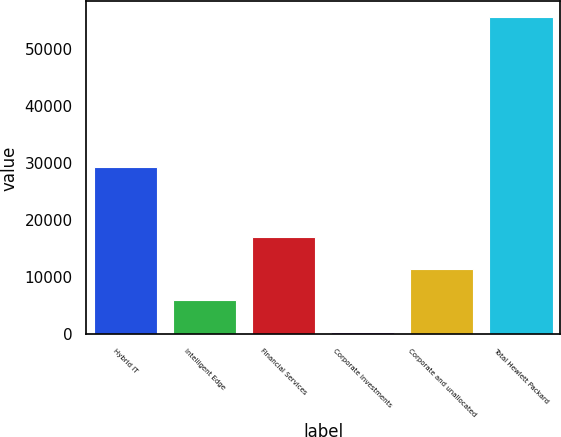Convert chart. <chart><loc_0><loc_0><loc_500><loc_500><bar_chart><fcel>Hybrid IT<fcel>Intelligent Edge<fcel>Financial Services<fcel>Corporate Investments<fcel>Corporate and unallocated<fcel>Total Hewlett Packard<nl><fcel>29342<fcel>5921.9<fcel>16937.7<fcel>414<fcel>11429.8<fcel>55493<nl></chart> 